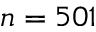<formula> <loc_0><loc_0><loc_500><loc_500>n = 5 0 1</formula> 